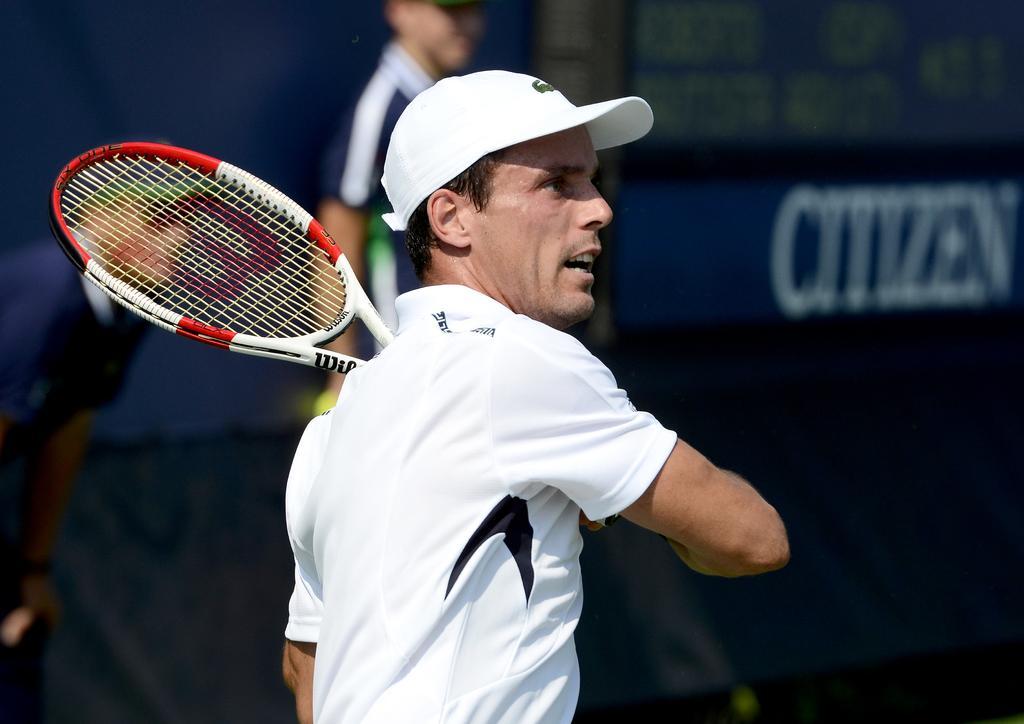In one or two sentences, can you explain what this image depicts? In this image, we can see a person is wearing a cap and open his mouth. Here we can see a racket. Background there is a blur view. Two people are here we can see. Top of the image, we can see a screen. 